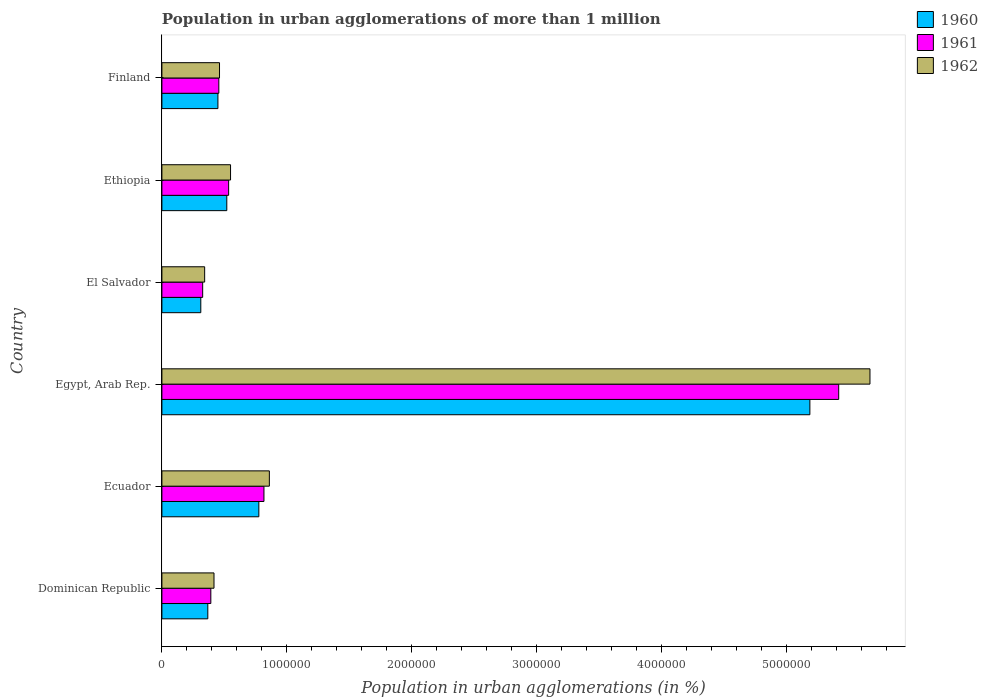How many different coloured bars are there?
Offer a very short reply. 3. How many groups of bars are there?
Your answer should be compact. 6. How many bars are there on the 5th tick from the bottom?
Keep it short and to the point. 3. What is the label of the 4th group of bars from the top?
Offer a terse response. Egypt, Arab Rep. What is the population in urban agglomerations in 1961 in Dominican Republic?
Provide a short and direct response. 3.91e+05. Across all countries, what is the maximum population in urban agglomerations in 1960?
Your answer should be compact. 5.18e+06. Across all countries, what is the minimum population in urban agglomerations in 1961?
Ensure brevity in your answer.  3.26e+05. In which country was the population in urban agglomerations in 1962 maximum?
Provide a succinct answer. Egypt, Arab Rep. In which country was the population in urban agglomerations in 1962 minimum?
Your response must be concise. El Salvador. What is the total population in urban agglomerations in 1960 in the graph?
Your answer should be compact. 7.61e+06. What is the difference between the population in urban agglomerations in 1962 in Ethiopia and that in Finland?
Your answer should be very brief. 8.82e+04. What is the difference between the population in urban agglomerations in 1962 in Ethiopia and the population in urban agglomerations in 1961 in Egypt, Arab Rep.?
Ensure brevity in your answer.  -4.87e+06. What is the average population in urban agglomerations in 1962 per country?
Make the answer very short. 1.38e+06. What is the difference between the population in urban agglomerations in 1962 and population in urban agglomerations in 1960 in Finland?
Ensure brevity in your answer.  1.28e+04. In how many countries, is the population in urban agglomerations in 1962 greater than 600000 %?
Your answer should be very brief. 2. What is the ratio of the population in urban agglomerations in 1962 in Ecuador to that in El Salvador?
Your response must be concise. 2.51. Is the population in urban agglomerations in 1961 in Dominican Republic less than that in Ecuador?
Offer a very short reply. Yes. Is the difference between the population in urban agglomerations in 1962 in Egypt, Arab Rep. and El Salvador greater than the difference between the population in urban agglomerations in 1960 in Egypt, Arab Rep. and El Salvador?
Offer a very short reply. Yes. What is the difference between the highest and the second highest population in urban agglomerations in 1962?
Your response must be concise. 4.81e+06. What is the difference between the highest and the lowest population in urban agglomerations in 1961?
Give a very brief answer. 5.09e+06. In how many countries, is the population in urban agglomerations in 1961 greater than the average population in urban agglomerations in 1961 taken over all countries?
Your answer should be very brief. 1. Is the sum of the population in urban agglomerations in 1961 in Dominican Republic and Ecuador greater than the maximum population in urban agglomerations in 1962 across all countries?
Your answer should be very brief. No. What does the 3rd bar from the bottom in Dominican Republic represents?
Provide a short and direct response. 1962. Is it the case that in every country, the sum of the population in urban agglomerations in 1960 and population in urban agglomerations in 1961 is greater than the population in urban agglomerations in 1962?
Your answer should be compact. Yes. How many bars are there?
Your answer should be compact. 18. Are the values on the major ticks of X-axis written in scientific E-notation?
Offer a terse response. No. Where does the legend appear in the graph?
Offer a very short reply. Top right. How many legend labels are there?
Offer a very short reply. 3. What is the title of the graph?
Give a very brief answer. Population in urban agglomerations of more than 1 million. Does "1972" appear as one of the legend labels in the graph?
Keep it short and to the point. No. What is the label or title of the X-axis?
Offer a terse response. Population in urban agglomerations (in %). What is the label or title of the Y-axis?
Keep it short and to the point. Country. What is the Population in urban agglomerations (in %) in 1960 in Dominican Republic?
Offer a terse response. 3.67e+05. What is the Population in urban agglomerations (in %) of 1961 in Dominican Republic?
Offer a very short reply. 3.91e+05. What is the Population in urban agglomerations (in %) in 1962 in Dominican Republic?
Keep it short and to the point. 4.17e+05. What is the Population in urban agglomerations (in %) of 1960 in Ecuador?
Provide a short and direct response. 7.76e+05. What is the Population in urban agglomerations (in %) in 1961 in Ecuador?
Your answer should be compact. 8.16e+05. What is the Population in urban agglomerations (in %) of 1962 in Ecuador?
Your answer should be very brief. 8.60e+05. What is the Population in urban agglomerations (in %) in 1960 in Egypt, Arab Rep.?
Offer a terse response. 5.18e+06. What is the Population in urban agglomerations (in %) of 1961 in Egypt, Arab Rep.?
Your answer should be very brief. 5.41e+06. What is the Population in urban agglomerations (in %) of 1962 in Egypt, Arab Rep.?
Offer a terse response. 5.66e+06. What is the Population in urban agglomerations (in %) in 1960 in El Salvador?
Your answer should be very brief. 3.11e+05. What is the Population in urban agglomerations (in %) of 1961 in El Salvador?
Offer a very short reply. 3.26e+05. What is the Population in urban agglomerations (in %) of 1962 in El Salvador?
Provide a succinct answer. 3.42e+05. What is the Population in urban agglomerations (in %) in 1960 in Ethiopia?
Make the answer very short. 5.19e+05. What is the Population in urban agglomerations (in %) of 1961 in Ethiopia?
Provide a succinct answer. 5.34e+05. What is the Population in urban agglomerations (in %) in 1962 in Ethiopia?
Offer a terse response. 5.49e+05. What is the Population in urban agglomerations (in %) of 1960 in Finland?
Your answer should be compact. 4.48e+05. What is the Population in urban agglomerations (in %) of 1961 in Finland?
Give a very brief answer. 4.55e+05. What is the Population in urban agglomerations (in %) in 1962 in Finland?
Offer a terse response. 4.61e+05. Across all countries, what is the maximum Population in urban agglomerations (in %) in 1960?
Your response must be concise. 5.18e+06. Across all countries, what is the maximum Population in urban agglomerations (in %) of 1961?
Offer a very short reply. 5.41e+06. Across all countries, what is the maximum Population in urban agglomerations (in %) in 1962?
Offer a terse response. 5.66e+06. Across all countries, what is the minimum Population in urban agglomerations (in %) in 1960?
Keep it short and to the point. 3.11e+05. Across all countries, what is the minimum Population in urban agglomerations (in %) in 1961?
Ensure brevity in your answer.  3.26e+05. Across all countries, what is the minimum Population in urban agglomerations (in %) of 1962?
Your answer should be very brief. 3.42e+05. What is the total Population in urban agglomerations (in %) in 1960 in the graph?
Your response must be concise. 7.61e+06. What is the total Population in urban agglomerations (in %) in 1961 in the graph?
Your answer should be compact. 7.94e+06. What is the total Population in urban agglomerations (in %) in 1962 in the graph?
Your answer should be compact. 8.29e+06. What is the difference between the Population in urban agglomerations (in %) in 1960 in Dominican Republic and that in Ecuador?
Offer a very short reply. -4.08e+05. What is the difference between the Population in urban agglomerations (in %) in 1961 in Dominican Republic and that in Ecuador?
Make the answer very short. -4.25e+05. What is the difference between the Population in urban agglomerations (in %) in 1962 in Dominican Republic and that in Ecuador?
Give a very brief answer. -4.43e+05. What is the difference between the Population in urban agglomerations (in %) in 1960 in Dominican Republic and that in Egypt, Arab Rep.?
Your answer should be very brief. -4.82e+06. What is the difference between the Population in urban agglomerations (in %) in 1961 in Dominican Republic and that in Egypt, Arab Rep.?
Ensure brevity in your answer.  -5.02e+06. What is the difference between the Population in urban agglomerations (in %) in 1962 in Dominican Republic and that in Egypt, Arab Rep.?
Your answer should be very brief. -5.25e+06. What is the difference between the Population in urban agglomerations (in %) in 1960 in Dominican Republic and that in El Salvador?
Offer a very short reply. 5.61e+04. What is the difference between the Population in urban agglomerations (in %) of 1961 in Dominican Republic and that in El Salvador?
Ensure brevity in your answer.  6.52e+04. What is the difference between the Population in urban agglomerations (in %) of 1962 in Dominican Republic and that in El Salvador?
Your answer should be very brief. 7.48e+04. What is the difference between the Population in urban agglomerations (in %) in 1960 in Dominican Republic and that in Ethiopia?
Your answer should be very brief. -1.52e+05. What is the difference between the Population in urban agglomerations (in %) in 1961 in Dominican Republic and that in Ethiopia?
Give a very brief answer. -1.43e+05. What is the difference between the Population in urban agglomerations (in %) of 1962 in Dominican Republic and that in Ethiopia?
Offer a very short reply. -1.32e+05. What is the difference between the Population in urban agglomerations (in %) of 1960 in Dominican Republic and that in Finland?
Offer a terse response. -8.09e+04. What is the difference between the Population in urban agglomerations (in %) of 1961 in Dominican Republic and that in Finland?
Your answer should be very brief. -6.41e+04. What is the difference between the Population in urban agglomerations (in %) in 1962 in Dominican Republic and that in Finland?
Offer a terse response. -4.42e+04. What is the difference between the Population in urban agglomerations (in %) in 1960 in Ecuador and that in Egypt, Arab Rep.?
Keep it short and to the point. -4.41e+06. What is the difference between the Population in urban agglomerations (in %) of 1961 in Ecuador and that in Egypt, Arab Rep.?
Provide a short and direct response. -4.60e+06. What is the difference between the Population in urban agglomerations (in %) of 1962 in Ecuador and that in Egypt, Arab Rep.?
Make the answer very short. -4.81e+06. What is the difference between the Population in urban agglomerations (in %) in 1960 in Ecuador and that in El Salvador?
Make the answer very short. 4.64e+05. What is the difference between the Population in urban agglomerations (in %) of 1961 in Ecuador and that in El Salvador?
Give a very brief answer. 4.90e+05. What is the difference between the Population in urban agglomerations (in %) of 1962 in Ecuador and that in El Salvador?
Keep it short and to the point. 5.18e+05. What is the difference between the Population in urban agglomerations (in %) in 1960 in Ecuador and that in Ethiopia?
Offer a terse response. 2.56e+05. What is the difference between the Population in urban agglomerations (in %) in 1961 in Ecuador and that in Ethiopia?
Provide a short and direct response. 2.83e+05. What is the difference between the Population in urban agglomerations (in %) in 1962 in Ecuador and that in Ethiopia?
Your answer should be very brief. 3.11e+05. What is the difference between the Population in urban agglomerations (in %) of 1960 in Ecuador and that in Finland?
Your answer should be compact. 3.27e+05. What is the difference between the Population in urban agglomerations (in %) in 1961 in Ecuador and that in Finland?
Your answer should be very brief. 3.61e+05. What is the difference between the Population in urban agglomerations (in %) of 1962 in Ecuador and that in Finland?
Your answer should be compact. 3.99e+05. What is the difference between the Population in urban agglomerations (in %) of 1960 in Egypt, Arab Rep. and that in El Salvador?
Provide a succinct answer. 4.87e+06. What is the difference between the Population in urban agglomerations (in %) in 1961 in Egypt, Arab Rep. and that in El Salvador?
Give a very brief answer. 5.09e+06. What is the difference between the Population in urban agglomerations (in %) of 1962 in Egypt, Arab Rep. and that in El Salvador?
Your answer should be compact. 5.32e+06. What is the difference between the Population in urban agglomerations (in %) of 1960 in Egypt, Arab Rep. and that in Ethiopia?
Keep it short and to the point. 4.66e+06. What is the difference between the Population in urban agglomerations (in %) of 1961 in Egypt, Arab Rep. and that in Ethiopia?
Keep it short and to the point. 4.88e+06. What is the difference between the Population in urban agglomerations (in %) in 1962 in Egypt, Arab Rep. and that in Ethiopia?
Keep it short and to the point. 5.12e+06. What is the difference between the Population in urban agglomerations (in %) in 1960 in Egypt, Arab Rep. and that in Finland?
Keep it short and to the point. 4.74e+06. What is the difference between the Population in urban agglomerations (in %) in 1961 in Egypt, Arab Rep. and that in Finland?
Provide a short and direct response. 4.96e+06. What is the difference between the Population in urban agglomerations (in %) of 1962 in Egypt, Arab Rep. and that in Finland?
Ensure brevity in your answer.  5.20e+06. What is the difference between the Population in urban agglomerations (in %) of 1960 in El Salvador and that in Ethiopia?
Ensure brevity in your answer.  -2.08e+05. What is the difference between the Population in urban agglomerations (in %) of 1961 in El Salvador and that in Ethiopia?
Your answer should be compact. -2.08e+05. What is the difference between the Population in urban agglomerations (in %) of 1962 in El Salvador and that in Ethiopia?
Your answer should be very brief. -2.07e+05. What is the difference between the Population in urban agglomerations (in %) of 1960 in El Salvador and that in Finland?
Offer a very short reply. -1.37e+05. What is the difference between the Population in urban agglomerations (in %) in 1961 in El Salvador and that in Finland?
Offer a very short reply. -1.29e+05. What is the difference between the Population in urban agglomerations (in %) of 1962 in El Salvador and that in Finland?
Your answer should be compact. -1.19e+05. What is the difference between the Population in urban agglomerations (in %) in 1960 in Ethiopia and that in Finland?
Make the answer very short. 7.10e+04. What is the difference between the Population in urban agglomerations (in %) of 1961 in Ethiopia and that in Finland?
Your response must be concise. 7.85e+04. What is the difference between the Population in urban agglomerations (in %) of 1962 in Ethiopia and that in Finland?
Offer a very short reply. 8.82e+04. What is the difference between the Population in urban agglomerations (in %) in 1960 in Dominican Republic and the Population in urban agglomerations (in %) in 1961 in Ecuador?
Give a very brief answer. -4.49e+05. What is the difference between the Population in urban agglomerations (in %) in 1960 in Dominican Republic and the Population in urban agglomerations (in %) in 1962 in Ecuador?
Offer a very short reply. -4.92e+05. What is the difference between the Population in urban agglomerations (in %) in 1961 in Dominican Republic and the Population in urban agglomerations (in %) in 1962 in Ecuador?
Provide a short and direct response. -4.68e+05. What is the difference between the Population in urban agglomerations (in %) of 1960 in Dominican Republic and the Population in urban agglomerations (in %) of 1961 in Egypt, Arab Rep.?
Your answer should be compact. -5.05e+06. What is the difference between the Population in urban agglomerations (in %) in 1960 in Dominican Republic and the Population in urban agglomerations (in %) in 1962 in Egypt, Arab Rep.?
Make the answer very short. -5.30e+06. What is the difference between the Population in urban agglomerations (in %) in 1961 in Dominican Republic and the Population in urban agglomerations (in %) in 1962 in Egypt, Arab Rep.?
Offer a very short reply. -5.27e+06. What is the difference between the Population in urban agglomerations (in %) in 1960 in Dominican Republic and the Population in urban agglomerations (in %) in 1961 in El Salvador?
Offer a very short reply. 4.11e+04. What is the difference between the Population in urban agglomerations (in %) in 1960 in Dominican Republic and the Population in urban agglomerations (in %) in 1962 in El Salvador?
Offer a very short reply. 2.53e+04. What is the difference between the Population in urban agglomerations (in %) in 1961 in Dominican Republic and the Population in urban agglomerations (in %) in 1962 in El Salvador?
Give a very brief answer. 4.94e+04. What is the difference between the Population in urban agglomerations (in %) of 1960 in Dominican Republic and the Population in urban agglomerations (in %) of 1961 in Ethiopia?
Provide a short and direct response. -1.67e+05. What is the difference between the Population in urban agglomerations (in %) of 1960 in Dominican Republic and the Population in urban agglomerations (in %) of 1962 in Ethiopia?
Provide a short and direct response. -1.82e+05. What is the difference between the Population in urban agglomerations (in %) in 1961 in Dominican Republic and the Population in urban agglomerations (in %) in 1962 in Ethiopia?
Offer a terse response. -1.58e+05. What is the difference between the Population in urban agglomerations (in %) of 1960 in Dominican Republic and the Population in urban agglomerations (in %) of 1961 in Finland?
Keep it short and to the point. -8.82e+04. What is the difference between the Population in urban agglomerations (in %) of 1960 in Dominican Republic and the Population in urban agglomerations (in %) of 1962 in Finland?
Give a very brief answer. -9.36e+04. What is the difference between the Population in urban agglomerations (in %) of 1961 in Dominican Republic and the Population in urban agglomerations (in %) of 1962 in Finland?
Offer a very short reply. -6.95e+04. What is the difference between the Population in urban agglomerations (in %) of 1960 in Ecuador and the Population in urban agglomerations (in %) of 1961 in Egypt, Arab Rep.?
Provide a short and direct response. -4.64e+06. What is the difference between the Population in urban agglomerations (in %) of 1960 in Ecuador and the Population in urban agglomerations (in %) of 1962 in Egypt, Arab Rep.?
Keep it short and to the point. -4.89e+06. What is the difference between the Population in urban agglomerations (in %) in 1961 in Ecuador and the Population in urban agglomerations (in %) in 1962 in Egypt, Arab Rep.?
Keep it short and to the point. -4.85e+06. What is the difference between the Population in urban agglomerations (in %) of 1960 in Ecuador and the Population in urban agglomerations (in %) of 1961 in El Salvador?
Your response must be concise. 4.49e+05. What is the difference between the Population in urban agglomerations (in %) of 1960 in Ecuador and the Population in urban agglomerations (in %) of 1962 in El Salvador?
Provide a short and direct response. 4.34e+05. What is the difference between the Population in urban agglomerations (in %) in 1961 in Ecuador and the Population in urban agglomerations (in %) in 1962 in El Salvador?
Provide a short and direct response. 4.74e+05. What is the difference between the Population in urban agglomerations (in %) of 1960 in Ecuador and the Population in urban agglomerations (in %) of 1961 in Ethiopia?
Your answer should be compact. 2.42e+05. What is the difference between the Population in urban agglomerations (in %) of 1960 in Ecuador and the Population in urban agglomerations (in %) of 1962 in Ethiopia?
Ensure brevity in your answer.  2.26e+05. What is the difference between the Population in urban agglomerations (in %) in 1961 in Ecuador and the Population in urban agglomerations (in %) in 1962 in Ethiopia?
Make the answer very short. 2.67e+05. What is the difference between the Population in urban agglomerations (in %) in 1960 in Ecuador and the Population in urban agglomerations (in %) in 1961 in Finland?
Provide a succinct answer. 3.20e+05. What is the difference between the Population in urban agglomerations (in %) in 1960 in Ecuador and the Population in urban agglomerations (in %) in 1962 in Finland?
Make the answer very short. 3.15e+05. What is the difference between the Population in urban agglomerations (in %) in 1961 in Ecuador and the Population in urban agglomerations (in %) in 1962 in Finland?
Make the answer very short. 3.56e+05. What is the difference between the Population in urban agglomerations (in %) in 1960 in Egypt, Arab Rep. and the Population in urban agglomerations (in %) in 1961 in El Salvador?
Ensure brevity in your answer.  4.86e+06. What is the difference between the Population in urban agglomerations (in %) of 1960 in Egypt, Arab Rep. and the Population in urban agglomerations (in %) of 1962 in El Salvador?
Your response must be concise. 4.84e+06. What is the difference between the Population in urban agglomerations (in %) of 1961 in Egypt, Arab Rep. and the Population in urban agglomerations (in %) of 1962 in El Salvador?
Make the answer very short. 5.07e+06. What is the difference between the Population in urban agglomerations (in %) of 1960 in Egypt, Arab Rep. and the Population in urban agglomerations (in %) of 1961 in Ethiopia?
Provide a short and direct response. 4.65e+06. What is the difference between the Population in urban agglomerations (in %) of 1960 in Egypt, Arab Rep. and the Population in urban agglomerations (in %) of 1962 in Ethiopia?
Provide a succinct answer. 4.63e+06. What is the difference between the Population in urban agglomerations (in %) in 1961 in Egypt, Arab Rep. and the Population in urban agglomerations (in %) in 1962 in Ethiopia?
Your answer should be very brief. 4.87e+06. What is the difference between the Population in urban agglomerations (in %) of 1960 in Egypt, Arab Rep. and the Population in urban agglomerations (in %) of 1961 in Finland?
Give a very brief answer. 4.73e+06. What is the difference between the Population in urban agglomerations (in %) in 1960 in Egypt, Arab Rep. and the Population in urban agglomerations (in %) in 1962 in Finland?
Your answer should be compact. 4.72e+06. What is the difference between the Population in urban agglomerations (in %) of 1961 in Egypt, Arab Rep. and the Population in urban agglomerations (in %) of 1962 in Finland?
Your answer should be compact. 4.95e+06. What is the difference between the Population in urban agglomerations (in %) in 1960 in El Salvador and the Population in urban agglomerations (in %) in 1961 in Ethiopia?
Your answer should be compact. -2.23e+05. What is the difference between the Population in urban agglomerations (in %) of 1960 in El Salvador and the Population in urban agglomerations (in %) of 1962 in Ethiopia?
Ensure brevity in your answer.  -2.38e+05. What is the difference between the Population in urban agglomerations (in %) of 1961 in El Salvador and the Population in urban agglomerations (in %) of 1962 in Ethiopia?
Keep it short and to the point. -2.23e+05. What is the difference between the Population in urban agglomerations (in %) in 1960 in El Salvador and the Population in urban agglomerations (in %) in 1961 in Finland?
Keep it short and to the point. -1.44e+05. What is the difference between the Population in urban agglomerations (in %) of 1960 in El Salvador and the Population in urban agglomerations (in %) of 1962 in Finland?
Keep it short and to the point. -1.50e+05. What is the difference between the Population in urban agglomerations (in %) in 1961 in El Salvador and the Population in urban agglomerations (in %) in 1962 in Finland?
Offer a very short reply. -1.35e+05. What is the difference between the Population in urban agglomerations (in %) in 1960 in Ethiopia and the Population in urban agglomerations (in %) in 1961 in Finland?
Provide a succinct answer. 6.37e+04. What is the difference between the Population in urban agglomerations (in %) of 1960 in Ethiopia and the Population in urban agglomerations (in %) of 1962 in Finland?
Make the answer very short. 5.82e+04. What is the difference between the Population in urban agglomerations (in %) of 1961 in Ethiopia and the Population in urban agglomerations (in %) of 1962 in Finland?
Your response must be concise. 7.30e+04. What is the average Population in urban agglomerations (in %) of 1960 per country?
Offer a very short reply. 1.27e+06. What is the average Population in urban agglomerations (in %) of 1961 per country?
Offer a terse response. 1.32e+06. What is the average Population in urban agglomerations (in %) in 1962 per country?
Offer a very short reply. 1.38e+06. What is the difference between the Population in urban agglomerations (in %) of 1960 and Population in urban agglomerations (in %) of 1961 in Dominican Republic?
Provide a short and direct response. -2.41e+04. What is the difference between the Population in urban agglomerations (in %) in 1960 and Population in urban agglomerations (in %) in 1962 in Dominican Republic?
Provide a short and direct response. -4.95e+04. What is the difference between the Population in urban agglomerations (in %) of 1961 and Population in urban agglomerations (in %) of 1962 in Dominican Republic?
Make the answer very short. -2.54e+04. What is the difference between the Population in urban agglomerations (in %) of 1960 and Population in urban agglomerations (in %) of 1961 in Ecuador?
Keep it short and to the point. -4.09e+04. What is the difference between the Population in urban agglomerations (in %) in 1960 and Population in urban agglomerations (in %) in 1962 in Ecuador?
Make the answer very short. -8.41e+04. What is the difference between the Population in urban agglomerations (in %) in 1961 and Population in urban agglomerations (in %) in 1962 in Ecuador?
Keep it short and to the point. -4.32e+04. What is the difference between the Population in urban agglomerations (in %) in 1960 and Population in urban agglomerations (in %) in 1961 in Egypt, Arab Rep.?
Your response must be concise. -2.31e+05. What is the difference between the Population in urban agglomerations (in %) in 1960 and Population in urban agglomerations (in %) in 1962 in Egypt, Arab Rep.?
Offer a very short reply. -4.81e+05. What is the difference between the Population in urban agglomerations (in %) of 1961 and Population in urban agglomerations (in %) of 1962 in Egypt, Arab Rep.?
Ensure brevity in your answer.  -2.50e+05. What is the difference between the Population in urban agglomerations (in %) of 1960 and Population in urban agglomerations (in %) of 1961 in El Salvador?
Keep it short and to the point. -1.50e+04. What is the difference between the Population in urban agglomerations (in %) in 1960 and Population in urban agglomerations (in %) in 1962 in El Salvador?
Make the answer very short. -3.08e+04. What is the difference between the Population in urban agglomerations (in %) in 1961 and Population in urban agglomerations (in %) in 1962 in El Salvador?
Your response must be concise. -1.58e+04. What is the difference between the Population in urban agglomerations (in %) of 1960 and Population in urban agglomerations (in %) of 1961 in Ethiopia?
Provide a short and direct response. -1.48e+04. What is the difference between the Population in urban agglomerations (in %) in 1960 and Population in urban agglomerations (in %) in 1962 in Ethiopia?
Provide a succinct answer. -3.00e+04. What is the difference between the Population in urban agglomerations (in %) in 1961 and Population in urban agglomerations (in %) in 1962 in Ethiopia?
Provide a short and direct response. -1.52e+04. What is the difference between the Population in urban agglomerations (in %) of 1960 and Population in urban agglomerations (in %) of 1961 in Finland?
Ensure brevity in your answer.  -7296. What is the difference between the Population in urban agglomerations (in %) of 1960 and Population in urban agglomerations (in %) of 1962 in Finland?
Provide a succinct answer. -1.28e+04. What is the difference between the Population in urban agglomerations (in %) of 1961 and Population in urban agglomerations (in %) of 1962 in Finland?
Your answer should be very brief. -5485. What is the ratio of the Population in urban agglomerations (in %) of 1960 in Dominican Republic to that in Ecuador?
Your answer should be very brief. 0.47. What is the ratio of the Population in urban agglomerations (in %) in 1961 in Dominican Republic to that in Ecuador?
Give a very brief answer. 0.48. What is the ratio of the Population in urban agglomerations (in %) in 1962 in Dominican Republic to that in Ecuador?
Provide a short and direct response. 0.48. What is the ratio of the Population in urban agglomerations (in %) of 1960 in Dominican Republic to that in Egypt, Arab Rep.?
Offer a terse response. 0.07. What is the ratio of the Population in urban agglomerations (in %) of 1961 in Dominican Republic to that in Egypt, Arab Rep.?
Keep it short and to the point. 0.07. What is the ratio of the Population in urban agglomerations (in %) of 1962 in Dominican Republic to that in Egypt, Arab Rep.?
Your answer should be very brief. 0.07. What is the ratio of the Population in urban agglomerations (in %) in 1960 in Dominican Republic to that in El Salvador?
Offer a very short reply. 1.18. What is the ratio of the Population in urban agglomerations (in %) in 1961 in Dominican Republic to that in El Salvador?
Offer a very short reply. 1.2. What is the ratio of the Population in urban agglomerations (in %) in 1962 in Dominican Republic to that in El Salvador?
Your response must be concise. 1.22. What is the ratio of the Population in urban agglomerations (in %) in 1960 in Dominican Republic to that in Ethiopia?
Provide a succinct answer. 0.71. What is the ratio of the Population in urban agglomerations (in %) of 1961 in Dominican Republic to that in Ethiopia?
Your response must be concise. 0.73. What is the ratio of the Population in urban agglomerations (in %) in 1962 in Dominican Republic to that in Ethiopia?
Offer a terse response. 0.76. What is the ratio of the Population in urban agglomerations (in %) of 1960 in Dominican Republic to that in Finland?
Provide a succinct answer. 0.82. What is the ratio of the Population in urban agglomerations (in %) in 1961 in Dominican Republic to that in Finland?
Make the answer very short. 0.86. What is the ratio of the Population in urban agglomerations (in %) in 1962 in Dominican Republic to that in Finland?
Your answer should be very brief. 0.9. What is the ratio of the Population in urban agglomerations (in %) in 1960 in Ecuador to that in Egypt, Arab Rep.?
Ensure brevity in your answer.  0.15. What is the ratio of the Population in urban agglomerations (in %) in 1961 in Ecuador to that in Egypt, Arab Rep.?
Ensure brevity in your answer.  0.15. What is the ratio of the Population in urban agglomerations (in %) of 1962 in Ecuador to that in Egypt, Arab Rep.?
Provide a short and direct response. 0.15. What is the ratio of the Population in urban agglomerations (in %) in 1960 in Ecuador to that in El Salvador?
Your answer should be very brief. 2.49. What is the ratio of the Population in urban agglomerations (in %) of 1961 in Ecuador to that in El Salvador?
Your answer should be very brief. 2.5. What is the ratio of the Population in urban agglomerations (in %) in 1962 in Ecuador to that in El Salvador?
Provide a succinct answer. 2.51. What is the ratio of the Population in urban agglomerations (in %) in 1960 in Ecuador to that in Ethiopia?
Your response must be concise. 1.49. What is the ratio of the Population in urban agglomerations (in %) of 1961 in Ecuador to that in Ethiopia?
Make the answer very short. 1.53. What is the ratio of the Population in urban agglomerations (in %) in 1962 in Ecuador to that in Ethiopia?
Keep it short and to the point. 1.57. What is the ratio of the Population in urban agglomerations (in %) in 1960 in Ecuador to that in Finland?
Provide a short and direct response. 1.73. What is the ratio of the Population in urban agglomerations (in %) of 1961 in Ecuador to that in Finland?
Provide a short and direct response. 1.79. What is the ratio of the Population in urban agglomerations (in %) in 1962 in Ecuador to that in Finland?
Give a very brief answer. 1.86. What is the ratio of the Population in urban agglomerations (in %) of 1960 in Egypt, Arab Rep. to that in El Salvador?
Your answer should be very brief. 16.66. What is the ratio of the Population in urban agglomerations (in %) of 1961 in Egypt, Arab Rep. to that in El Salvador?
Your response must be concise. 16.6. What is the ratio of the Population in urban agglomerations (in %) in 1962 in Egypt, Arab Rep. to that in El Salvador?
Your answer should be compact. 16.56. What is the ratio of the Population in urban agglomerations (in %) in 1960 in Egypt, Arab Rep. to that in Ethiopia?
Offer a terse response. 9.98. What is the ratio of the Population in urban agglomerations (in %) of 1961 in Egypt, Arab Rep. to that in Ethiopia?
Give a very brief answer. 10.14. What is the ratio of the Population in urban agglomerations (in %) of 1962 in Egypt, Arab Rep. to that in Ethiopia?
Ensure brevity in your answer.  10.32. What is the ratio of the Population in urban agglomerations (in %) in 1960 in Egypt, Arab Rep. to that in Finland?
Keep it short and to the point. 11.57. What is the ratio of the Population in urban agglomerations (in %) of 1961 in Egypt, Arab Rep. to that in Finland?
Your response must be concise. 11.89. What is the ratio of the Population in urban agglomerations (in %) of 1962 in Egypt, Arab Rep. to that in Finland?
Your answer should be compact. 12.29. What is the ratio of the Population in urban agglomerations (in %) of 1960 in El Salvador to that in Ethiopia?
Provide a succinct answer. 0.6. What is the ratio of the Population in urban agglomerations (in %) of 1961 in El Salvador to that in Ethiopia?
Offer a terse response. 0.61. What is the ratio of the Population in urban agglomerations (in %) of 1962 in El Salvador to that in Ethiopia?
Your answer should be very brief. 0.62. What is the ratio of the Population in urban agglomerations (in %) of 1960 in El Salvador to that in Finland?
Provide a succinct answer. 0.69. What is the ratio of the Population in urban agglomerations (in %) in 1961 in El Salvador to that in Finland?
Give a very brief answer. 0.72. What is the ratio of the Population in urban agglomerations (in %) in 1962 in El Salvador to that in Finland?
Your response must be concise. 0.74. What is the ratio of the Population in urban agglomerations (in %) of 1960 in Ethiopia to that in Finland?
Keep it short and to the point. 1.16. What is the ratio of the Population in urban agglomerations (in %) in 1961 in Ethiopia to that in Finland?
Give a very brief answer. 1.17. What is the ratio of the Population in urban agglomerations (in %) of 1962 in Ethiopia to that in Finland?
Make the answer very short. 1.19. What is the difference between the highest and the second highest Population in urban agglomerations (in %) of 1960?
Ensure brevity in your answer.  4.41e+06. What is the difference between the highest and the second highest Population in urban agglomerations (in %) of 1961?
Offer a terse response. 4.60e+06. What is the difference between the highest and the second highest Population in urban agglomerations (in %) of 1962?
Keep it short and to the point. 4.81e+06. What is the difference between the highest and the lowest Population in urban agglomerations (in %) in 1960?
Offer a terse response. 4.87e+06. What is the difference between the highest and the lowest Population in urban agglomerations (in %) in 1961?
Your response must be concise. 5.09e+06. What is the difference between the highest and the lowest Population in urban agglomerations (in %) in 1962?
Make the answer very short. 5.32e+06. 